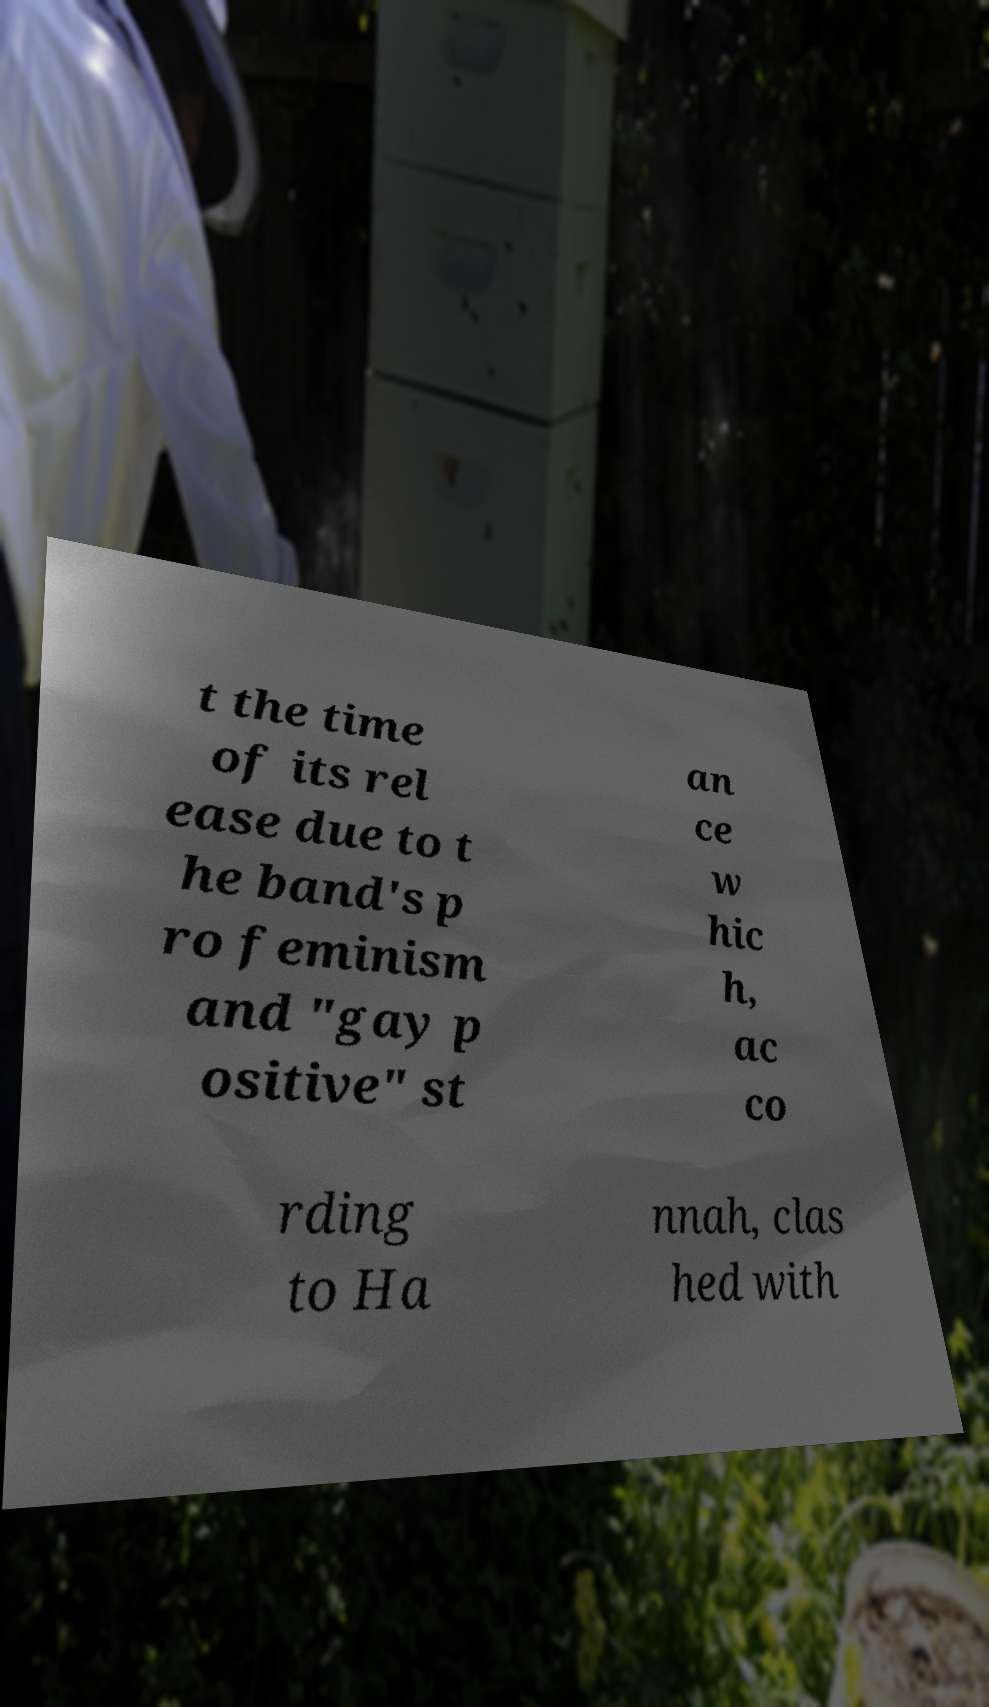Please read and relay the text visible in this image. What does it say? t the time of its rel ease due to t he band's p ro feminism and "gay p ositive" st an ce w hic h, ac co rding to Ha nnah, clas hed with 